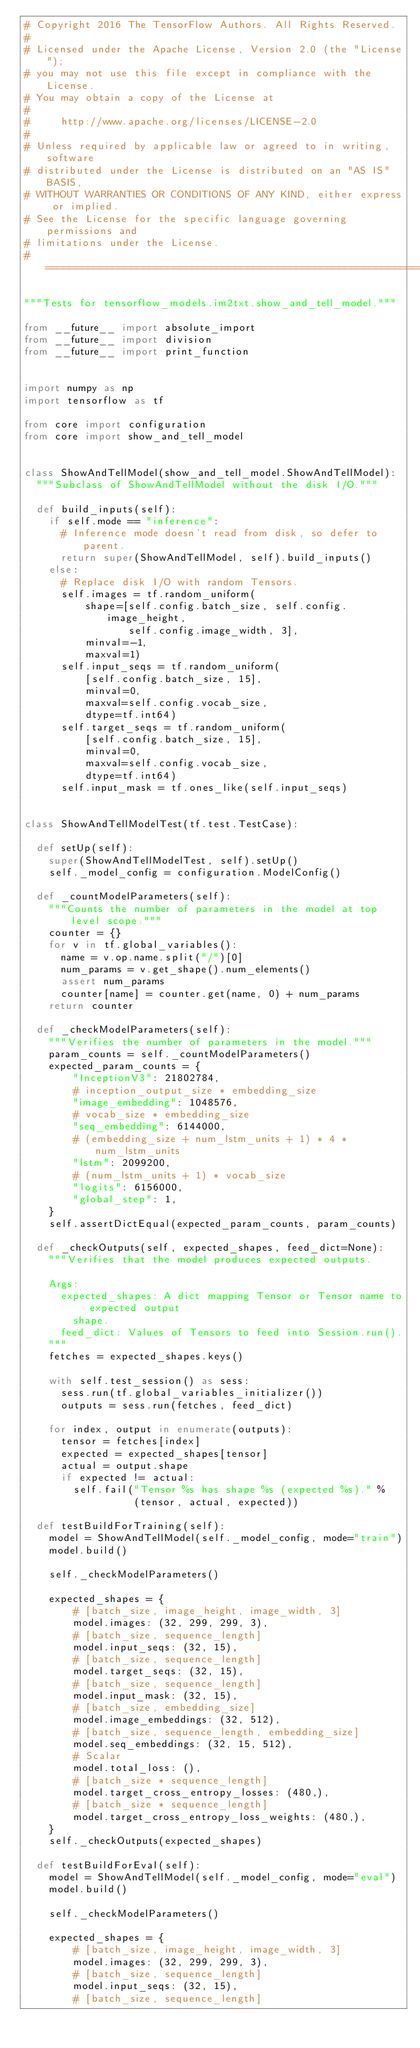Convert code to text. <code><loc_0><loc_0><loc_500><loc_500><_Python_># Copyright 2016 The TensorFlow Authors. All Rights Reserved.
#
# Licensed under the Apache License, Version 2.0 (the "License");
# you may not use this file except in compliance with the License.
# You may obtain a copy of the License at
#
#     http://www.apache.org/licenses/LICENSE-2.0
#
# Unless required by applicable law or agreed to in writing, software
# distributed under the License is distributed on an "AS IS" BASIS,
# WITHOUT WARRANTIES OR CONDITIONS OF ANY KIND, either express or implied.
# See the License for the specific language governing permissions and
# limitations under the License.
# ==============================================================================

"""Tests for tensorflow_models.im2txt.show_and_tell_model."""

from __future__ import absolute_import
from __future__ import division
from __future__ import print_function


import numpy as np
import tensorflow as tf

from core import configuration
from core import show_and_tell_model


class ShowAndTellModel(show_and_tell_model.ShowAndTellModel):
  """Subclass of ShowAndTellModel without the disk I/O."""

  def build_inputs(self):
    if self.mode == "inference":
      # Inference mode doesn't read from disk, so defer to parent.
      return super(ShowAndTellModel, self).build_inputs()
    else:
      # Replace disk I/O with random Tensors.
      self.images = tf.random_uniform(
          shape=[self.config.batch_size, self.config.image_height,
                 self.config.image_width, 3],
          minval=-1,
          maxval=1)
      self.input_seqs = tf.random_uniform(
          [self.config.batch_size, 15],
          minval=0,
          maxval=self.config.vocab_size,
          dtype=tf.int64)
      self.target_seqs = tf.random_uniform(
          [self.config.batch_size, 15],
          minval=0,
          maxval=self.config.vocab_size,
          dtype=tf.int64)
      self.input_mask = tf.ones_like(self.input_seqs)


class ShowAndTellModelTest(tf.test.TestCase):

  def setUp(self):
    super(ShowAndTellModelTest, self).setUp()
    self._model_config = configuration.ModelConfig()

  def _countModelParameters(self):
    """Counts the number of parameters in the model at top level scope."""
    counter = {}
    for v in tf.global_variables():
      name = v.op.name.split("/")[0]
      num_params = v.get_shape().num_elements()
      assert num_params
      counter[name] = counter.get(name, 0) + num_params
    return counter

  def _checkModelParameters(self):
    """Verifies the number of parameters in the model."""
    param_counts = self._countModelParameters()
    expected_param_counts = {
        "InceptionV3": 21802784,
        # inception_output_size * embedding_size
        "image_embedding": 1048576,
        # vocab_size * embedding_size
        "seq_embedding": 6144000,
        # (embedding_size + num_lstm_units + 1) * 4 * num_lstm_units
        "lstm": 2099200,
        # (num_lstm_units + 1) * vocab_size
        "logits": 6156000,
        "global_step": 1,
    }
    self.assertDictEqual(expected_param_counts, param_counts)

  def _checkOutputs(self, expected_shapes, feed_dict=None):
    """Verifies that the model produces expected outputs.

    Args:
      expected_shapes: A dict mapping Tensor or Tensor name to expected output
        shape.
      feed_dict: Values of Tensors to feed into Session.run().
    """
    fetches = expected_shapes.keys()

    with self.test_session() as sess:
      sess.run(tf.global_variables_initializer())
      outputs = sess.run(fetches, feed_dict)

    for index, output in enumerate(outputs):
      tensor = fetches[index]
      expected = expected_shapes[tensor]
      actual = output.shape
      if expected != actual:
        self.fail("Tensor %s has shape %s (expected %s)." %
                  (tensor, actual, expected))

  def testBuildForTraining(self):
    model = ShowAndTellModel(self._model_config, mode="train")
    model.build()

    self._checkModelParameters()

    expected_shapes = {
        # [batch_size, image_height, image_width, 3]
        model.images: (32, 299, 299, 3),
        # [batch_size, sequence_length]
        model.input_seqs: (32, 15),
        # [batch_size, sequence_length]
        model.target_seqs: (32, 15),
        # [batch_size, sequence_length]
        model.input_mask: (32, 15),
        # [batch_size, embedding_size]
        model.image_embeddings: (32, 512),
        # [batch_size, sequence_length, embedding_size]
        model.seq_embeddings: (32, 15, 512),
        # Scalar
        model.total_loss: (),
        # [batch_size * sequence_length]
        model.target_cross_entropy_losses: (480,),
        # [batch_size * sequence_length]
        model.target_cross_entropy_loss_weights: (480,),
    }
    self._checkOutputs(expected_shapes)

  def testBuildForEval(self):
    model = ShowAndTellModel(self._model_config, mode="eval")
    model.build()

    self._checkModelParameters()

    expected_shapes = {
        # [batch_size, image_height, image_width, 3]
        model.images: (32, 299, 299, 3),
        # [batch_size, sequence_length]
        model.input_seqs: (32, 15),
        # [batch_size, sequence_length]</code> 